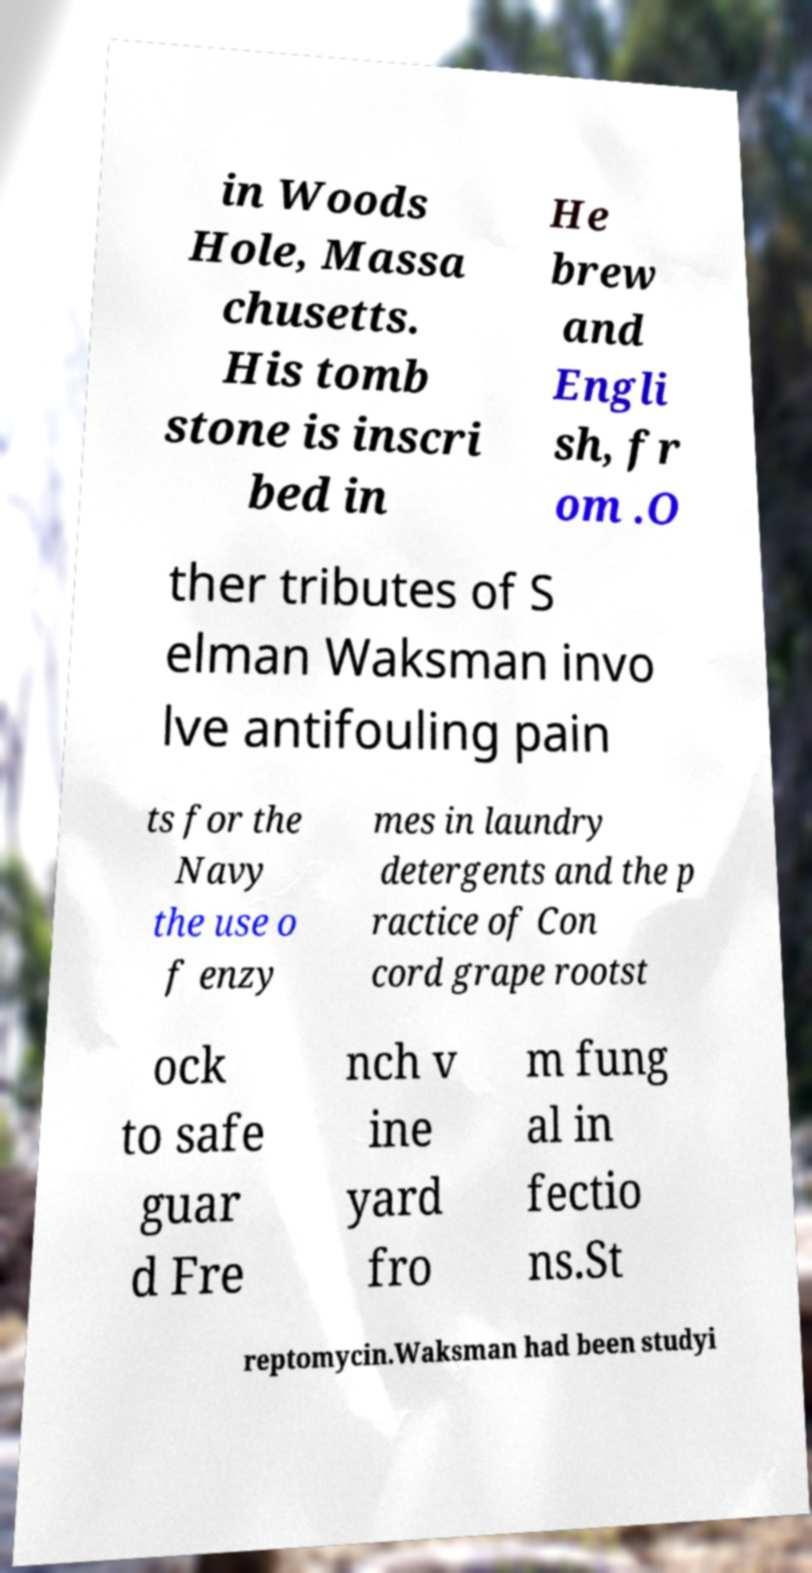Can you read and provide the text displayed in the image?This photo seems to have some interesting text. Can you extract and type it out for me? in Woods Hole, Massa chusetts. His tomb stone is inscri bed in He brew and Engli sh, fr om .O ther tributes of S elman Waksman invo lve antifouling pain ts for the Navy the use o f enzy mes in laundry detergents and the p ractice of Con cord grape rootst ock to safe guar d Fre nch v ine yard fro m fung al in fectio ns.St reptomycin.Waksman had been studyi 